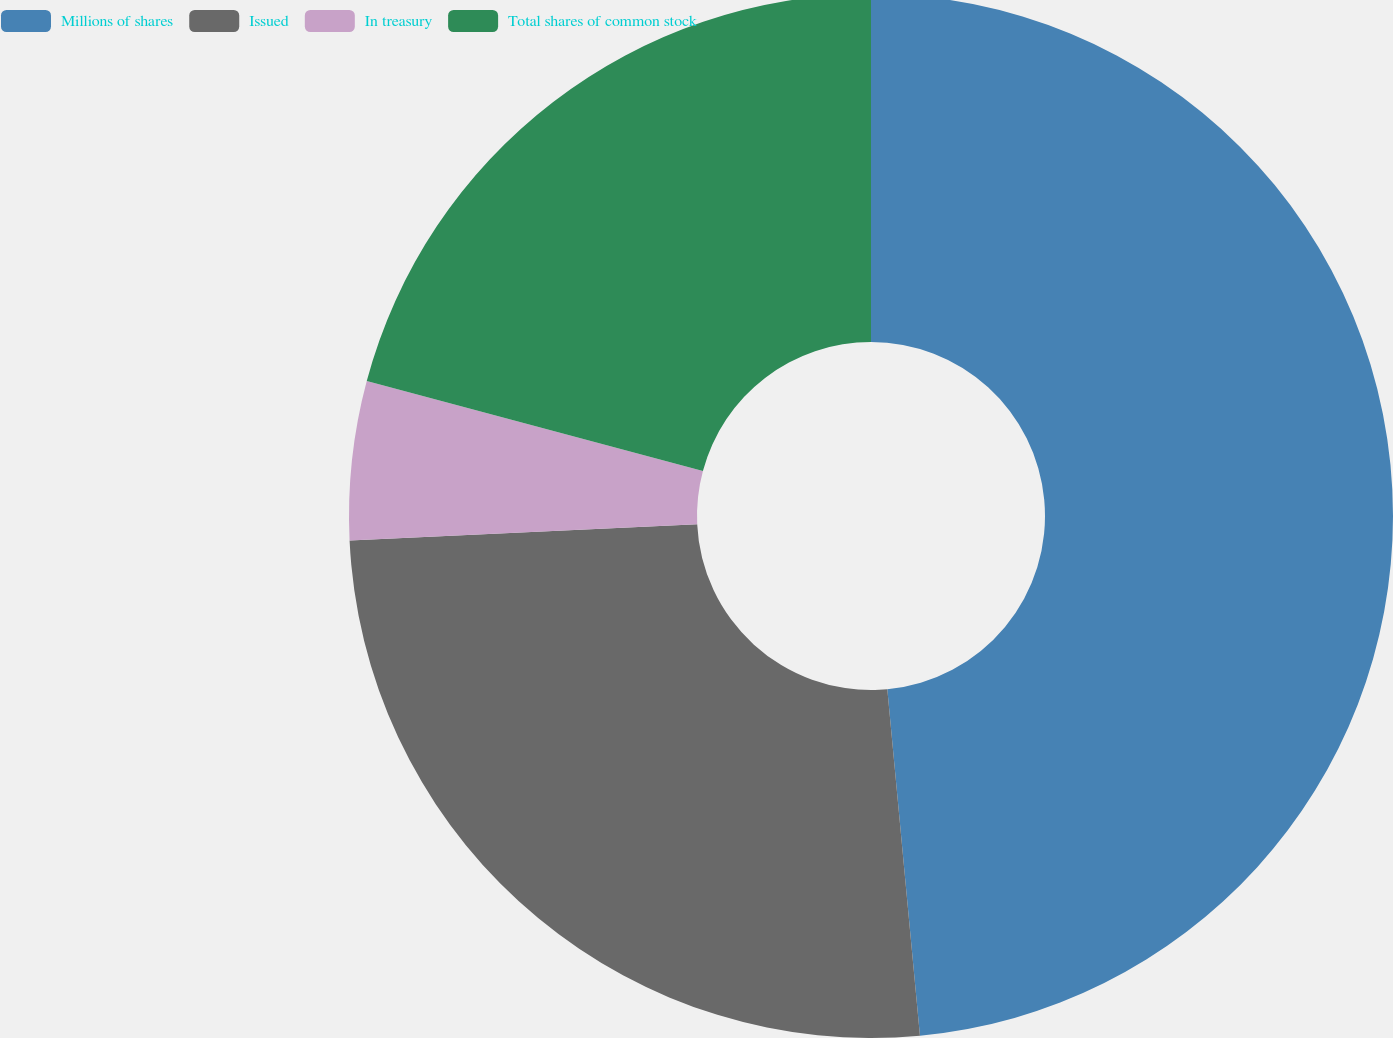Convert chart. <chart><loc_0><loc_0><loc_500><loc_500><pie_chart><fcel>Millions of shares<fcel>Issued<fcel>In treasury<fcel>Total shares of common stock<nl><fcel>48.51%<fcel>25.75%<fcel>4.91%<fcel>20.84%<nl></chart> 